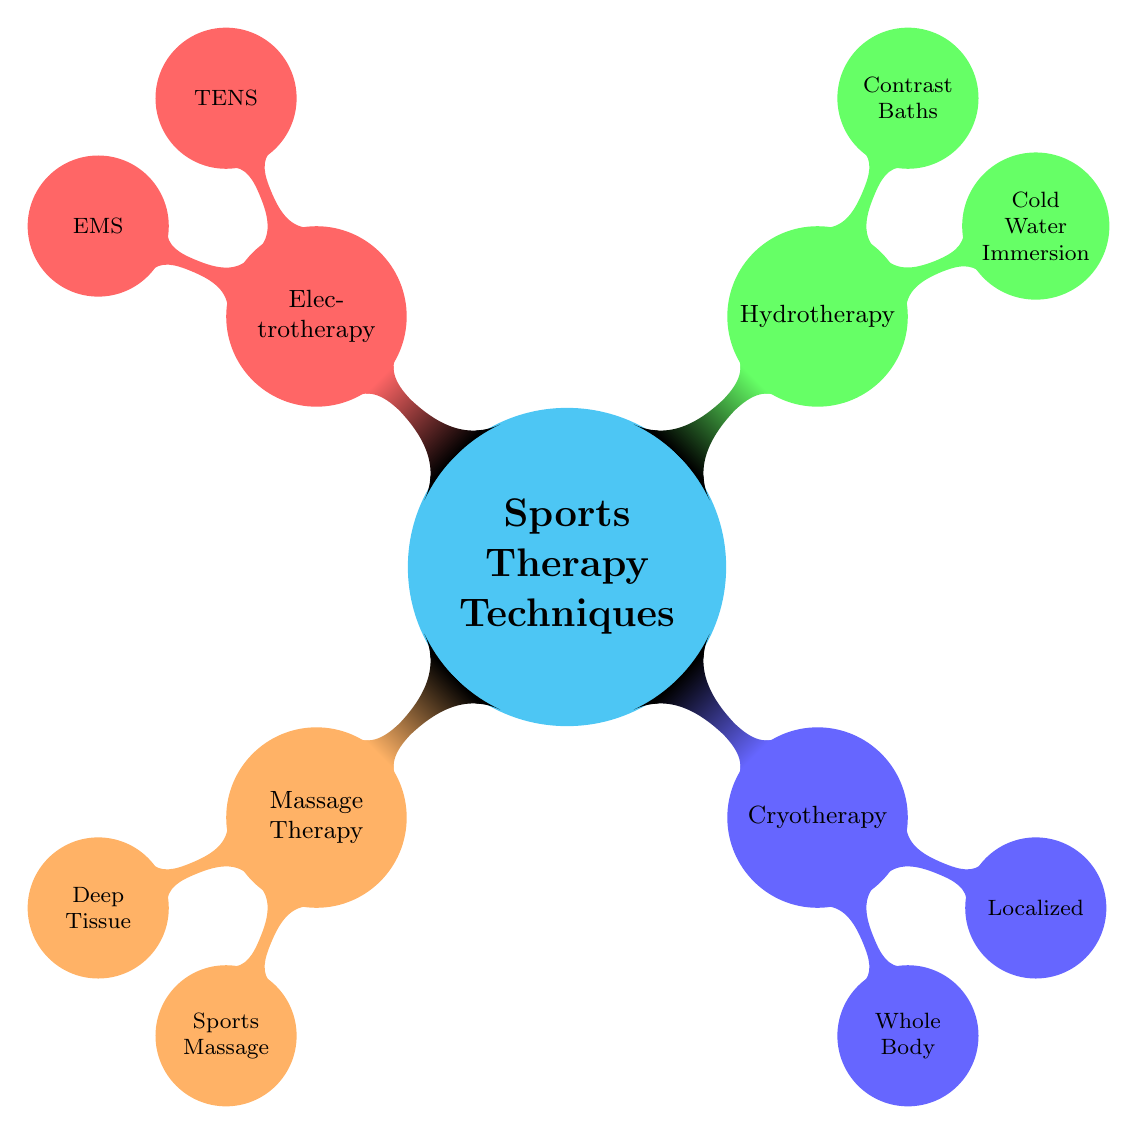What are the main categories of Sports Therapy Techniques? The diagram presents four main categories: Massage Therapy, Cryotherapy, Hydrotherapy, and Electrotherapy.
Answer: Massage Therapy, Cryotherapy, Hydrotherapy, Electrotherapy How many components are under Massage Therapy? Looking at the Massage Therapy node, there are two components listed: Deep Tissue Massage and Sports Massage. Thus, the total is two.
Answer: 2 What is the benefit of Whole Body Cryotherapy? The Whole Body Cryotherapy component lists "reduced inflammation" as one of its benefits. Therefore, this is the concise answer.
Answer: reduced inflammation Which technique focuses on pain management? Within the Electrotherapy category, TENS is specifically noted for focusing on pain management. Thus, the answer refers to this component.
Answer: TENS Which therapy technique is used for post-exercise recovery? The Cold Water Immersion, found under Hydrotherapy, is stated to be for post-exercise recovery. This indicates Cold Water Immersion is the correct answer.
Answer: Cold Water Immersion Which technique helps in muscle strengthening? The EMS component of Electrotherapy is explicitly designed to aid muscle strengthening, making it the right answer.
Answer: EMS What are the benefits of Contrast Baths? When reviewing the Contrast Baths node, it lists two benefits: "decreased muscle spasm" and "enhanced recovery." Therefore, both benefits are valid responses.
Answer: decreased muscle spasm, enhanced recovery Which type of cryotherapy provides targeted pain relief? Localized Cryotherapy is noted in the diagram to provide targeted pain relief. This indicates the specific technique catering to this need.
Answer: Localized Cryotherapy What is the primary focus of Sports Massage? The Sports Massage component specifically states its focus as "preventing injuries," indicating its preventive nature in athletic contexts.
Answer: preventing injuries 